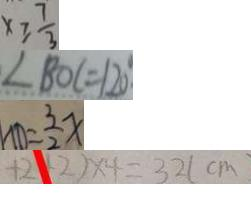<formula> <loc_0><loc_0><loc_500><loc_500>x \geq \frac { 7 } { 3 } 
 \angle B O C = 1 2 0 ^ { \circ } 
 N D = \frac { 3 } { 2 } x 
 + 2 + 2 ) \times 4 = 3 2 ( c m )</formula> 